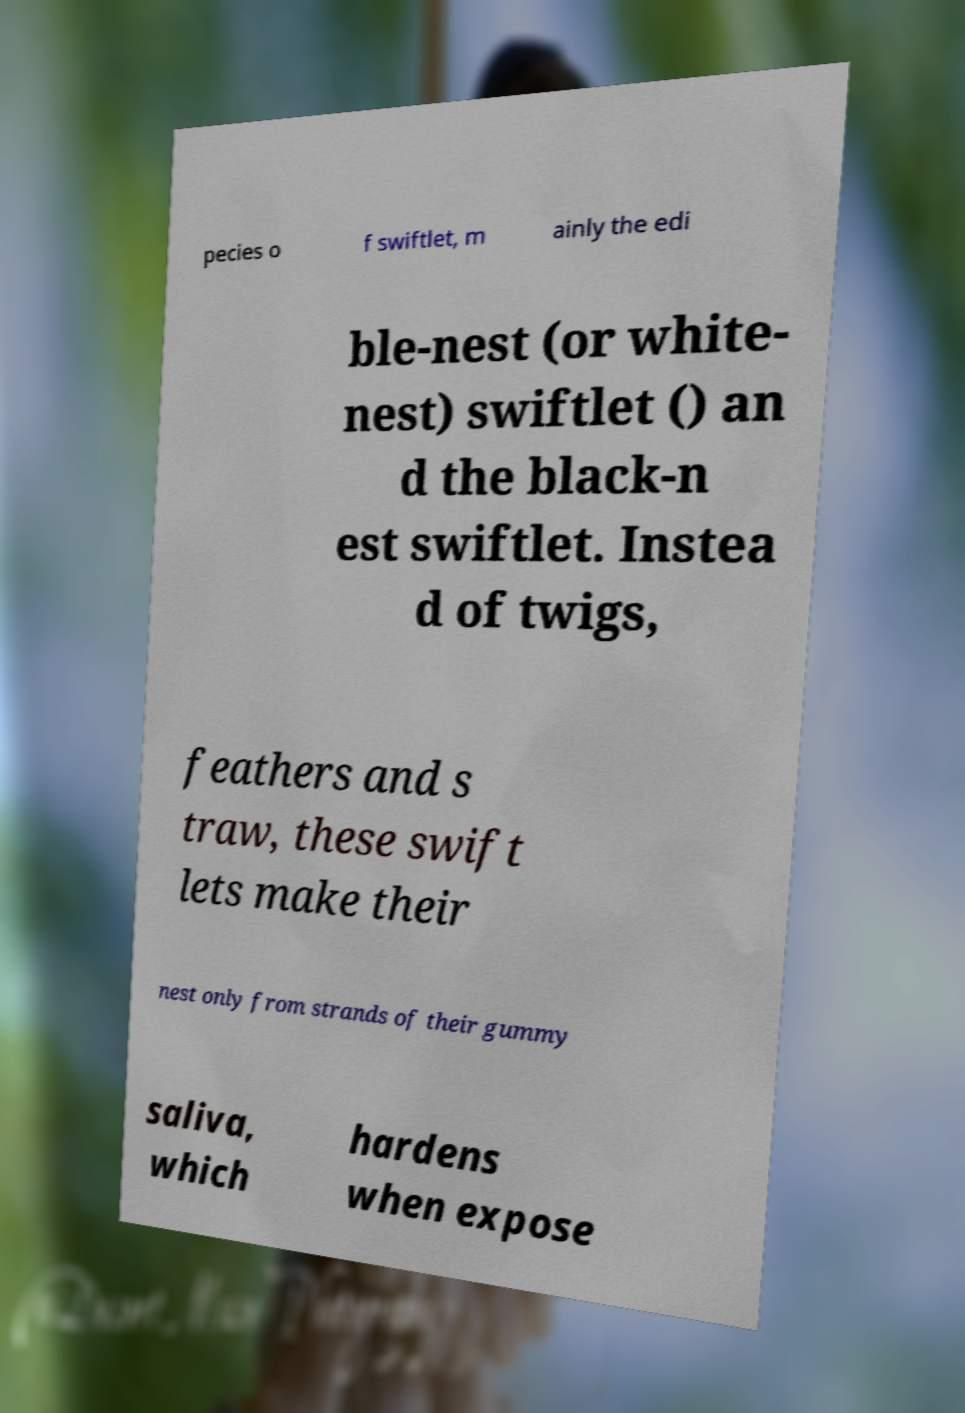I need the written content from this picture converted into text. Can you do that? pecies o f swiftlet, m ainly the edi ble-nest (or white- nest) swiftlet () an d the black-n est swiftlet. Instea d of twigs, feathers and s traw, these swift lets make their nest only from strands of their gummy saliva, which hardens when expose 